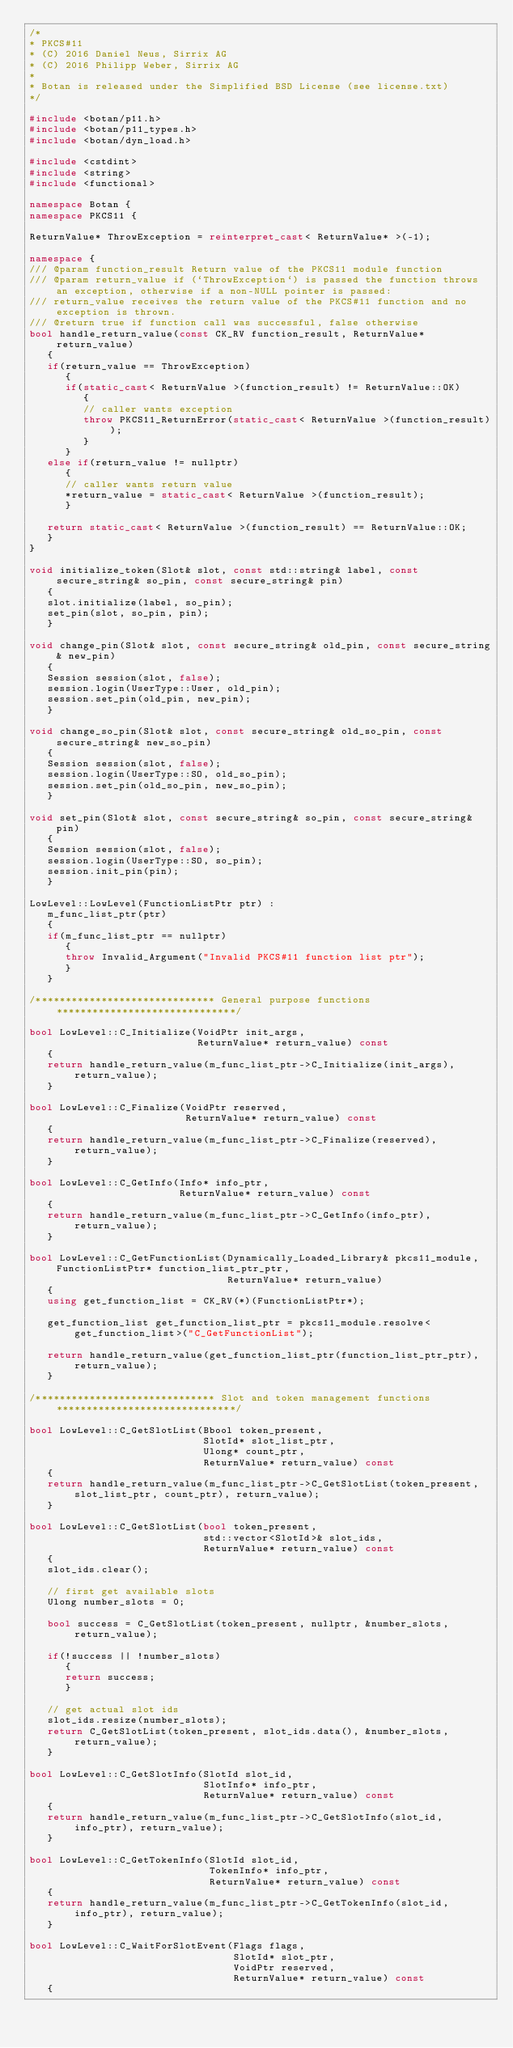<code> <loc_0><loc_0><loc_500><loc_500><_C++_>/*
* PKCS#11
* (C) 2016 Daniel Neus, Sirrix AG
* (C) 2016 Philipp Weber, Sirrix AG
*
* Botan is released under the Simplified BSD License (see license.txt)
*/

#include <botan/p11.h>
#include <botan/p11_types.h>
#include <botan/dyn_load.h>

#include <cstdint>
#include <string>
#include <functional>

namespace Botan {
namespace PKCS11 {

ReturnValue* ThrowException = reinterpret_cast< ReturnValue* >(-1);

namespace {
/// @param function_result Return value of the PKCS11 module function
/// @param return_value if (`ThrowException`) is passed the function throws an exception, otherwise if a non-NULL pointer is passed:
/// return_value receives the return value of the PKCS#11 function and no exception is thrown.
/// @return true if function call was successful, false otherwise
bool handle_return_value(const CK_RV function_result, ReturnValue* return_value)
   {
   if(return_value == ThrowException)
      {
      if(static_cast< ReturnValue >(function_result) != ReturnValue::OK)
         {
         // caller wants exception
         throw PKCS11_ReturnError(static_cast< ReturnValue >(function_result));
         }
      }
   else if(return_value != nullptr)
      {
      // caller wants return value
      *return_value = static_cast< ReturnValue >(function_result);
      }

   return static_cast< ReturnValue >(function_result) == ReturnValue::OK;
   }
}

void initialize_token(Slot& slot, const std::string& label, const secure_string& so_pin, const secure_string& pin)
   {
   slot.initialize(label, so_pin);
   set_pin(slot, so_pin, pin);
   }

void change_pin(Slot& slot, const secure_string& old_pin, const secure_string& new_pin)
   {
   Session session(slot, false);
   session.login(UserType::User, old_pin);
   session.set_pin(old_pin, new_pin);
   }

void change_so_pin(Slot& slot, const secure_string& old_so_pin, const secure_string& new_so_pin)
   {
   Session session(slot, false);
   session.login(UserType::SO, old_so_pin);
   session.set_pin(old_so_pin, new_so_pin);
   }

void set_pin(Slot& slot, const secure_string& so_pin, const secure_string& pin)
   {
   Session session(slot, false);
   session.login(UserType::SO, so_pin);
   session.init_pin(pin);
   }

LowLevel::LowLevel(FunctionListPtr ptr) :
   m_func_list_ptr(ptr)
   {
   if(m_func_list_ptr == nullptr)
      {
      throw Invalid_Argument("Invalid PKCS#11 function list ptr");
      }
   }

/****************************** General purpose functions ******************************/

bool LowLevel::C_Initialize(VoidPtr init_args,
                            ReturnValue* return_value) const
   {
   return handle_return_value(m_func_list_ptr->C_Initialize(init_args), return_value);
   }

bool LowLevel::C_Finalize(VoidPtr reserved,
                          ReturnValue* return_value) const
   {
   return handle_return_value(m_func_list_ptr->C_Finalize(reserved), return_value);
   }

bool LowLevel::C_GetInfo(Info* info_ptr,
                         ReturnValue* return_value) const
   {
   return handle_return_value(m_func_list_ptr->C_GetInfo(info_ptr), return_value);
   }

bool LowLevel::C_GetFunctionList(Dynamically_Loaded_Library& pkcs11_module, FunctionListPtr* function_list_ptr_ptr,
                                 ReturnValue* return_value)
   {
   using get_function_list = CK_RV(*)(FunctionListPtr*);

   get_function_list get_function_list_ptr = pkcs11_module.resolve<get_function_list>("C_GetFunctionList");

   return handle_return_value(get_function_list_ptr(function_list_ptr_ptr), return_value);
   }

/****************************** Slot and token management functions ******************************/

bool LowLevel::C_GetSlotList(Bbool token_present,
                             SlotId* slot_list_ptr,
                             Ulong* count_ptr,
                             ReturnValue* return_value) const
   {
   return handle_return_value(m_func_list_ptr->C_GetSlotList(token_present, slot_list_ptr, count_ptr), return_value);
   }

bool LowLevel::C_GetSlotList(bool token_present,
                             std::vector<SlotId>& slot_ids,
                             ReturnValue* return_value) const
   {
   slot_ids.clear();

   // first get available slots
   Ulong number_slots = 0;

   bool success = C_GetSlotList(token_present, nullptr, &number_slots, return_value);

   if(!success || !number_slots)
      {
      return success;
      }

   // get actual slot ids
   slot_ids.resize(number_slots);
   return C_GetSlotList(token_present, slot_ids.data(), &number_slots, return_value);
   }

bool LowLevel::C_GetSlotInfo(SlotId slot_id,
                             SlotInfo* info_ptr,
                             ReturnValue* return_value) const
   {
   return handle_return_value(m_func_list_ptr->C_GetSlotInfo(slot_id, info_ptr), return_value);
   }

bool LowLevel::C_GetTokenInfo(SlotId slot_id,
                              TokenInfo* info_ptr,
                              ReturnValue* return_value) const
   {
   return handle_return_value(m_func_list_ptr->C_GetTokenInfo(slot_id, info_ptr), return_value);
   }

bool LowLevel::C_WaitForSlotEvent(Flags flags,
                                  SlotId* slot_ptr,
                                  VoidPtr reserved,
                                  ReturnValue* return_value) const
   {</code> 